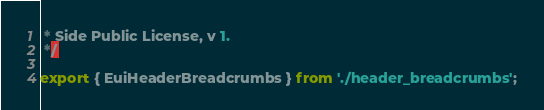Convert code to text. <code><loc_0><loc_0><loc_500><loc_500><_TypeScript_> * Side Public License, v 1.
 */

export { EuiHeaderBreadcrumbs } from './header_breadcrumbs';
</code> 